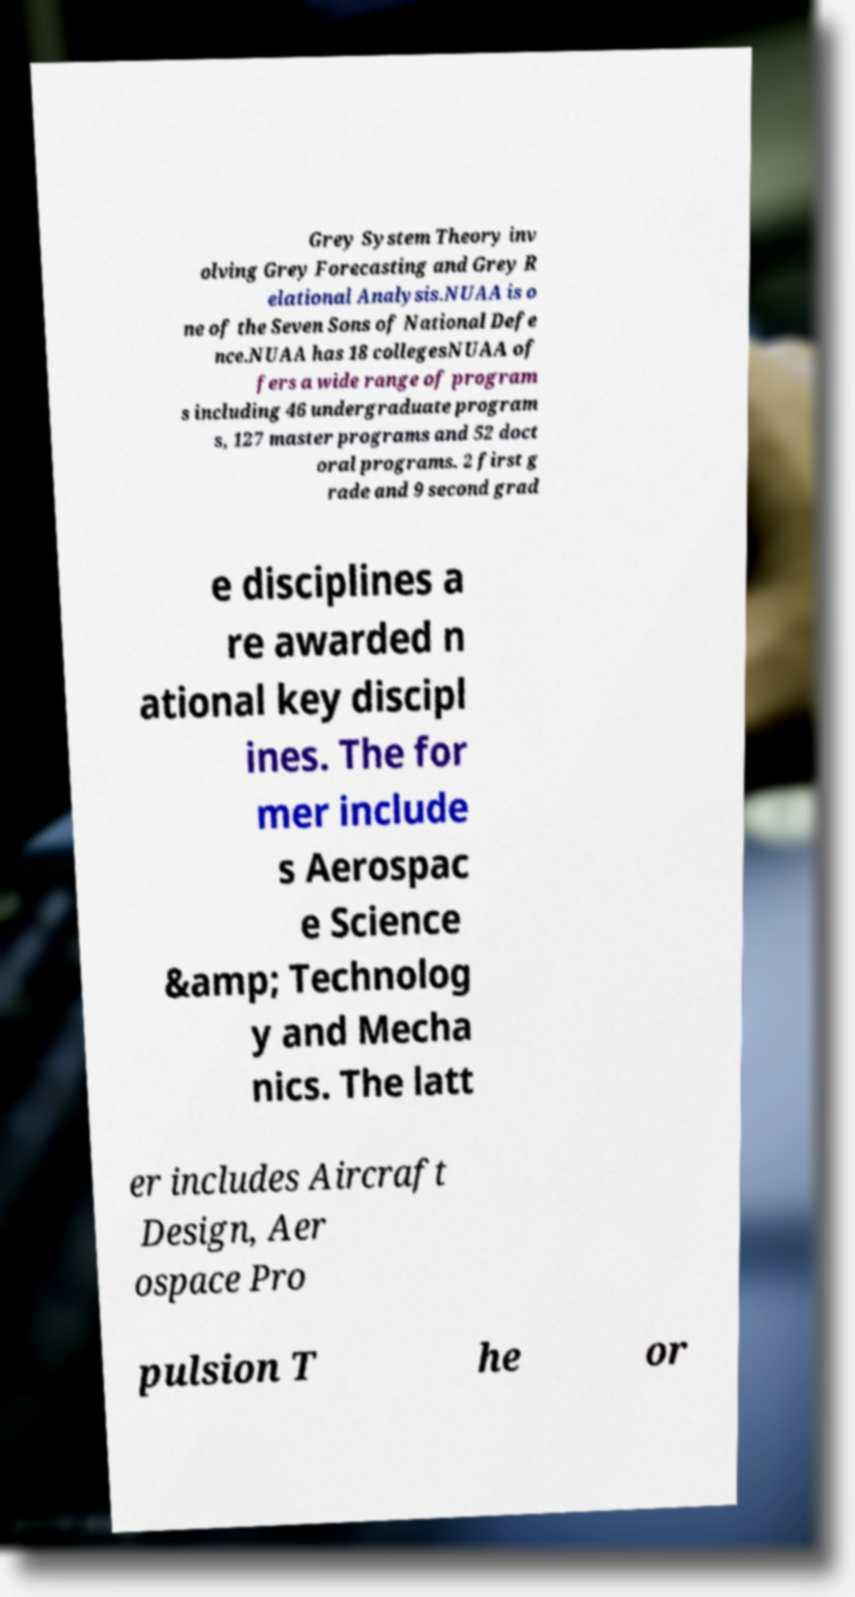Could you extract and type out the text from this image? Grey System Theory inv olving Grey Forecasting and Grey R elational Analysis.NUAA is o ne of the Seven Sons of National Defe nce.NUAA has 18 collegesNUAA of fers a wide range of program s including 46 undergraduate program s, 127 master programs and 52 doct oral programs. 2 first g rade and 9 second grad e disciplines a re awarded n ational key discipl ines. The for mer include s Aerospac e Science &amp; Technolog y and Mecha nics. The latt er includes Aircraft Design, Aer ospace Pro pulsion T he or 